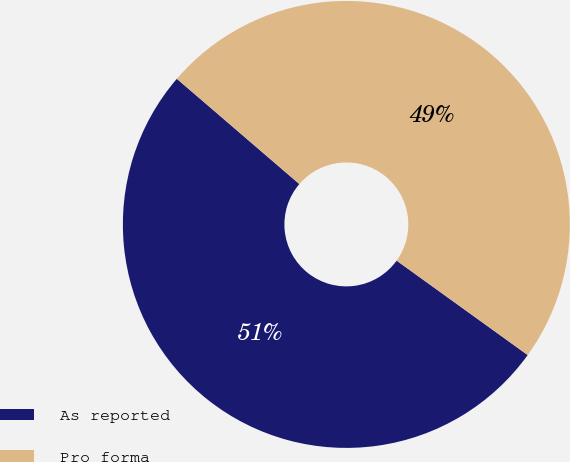Convert chart. <chart><loc_0><loc_0><loc_500><loc_500><pie_chart><fcel>As reported<fcel>Pro forma<nl><fcel>51.36%<fcel>48.64%<nl></chart> 